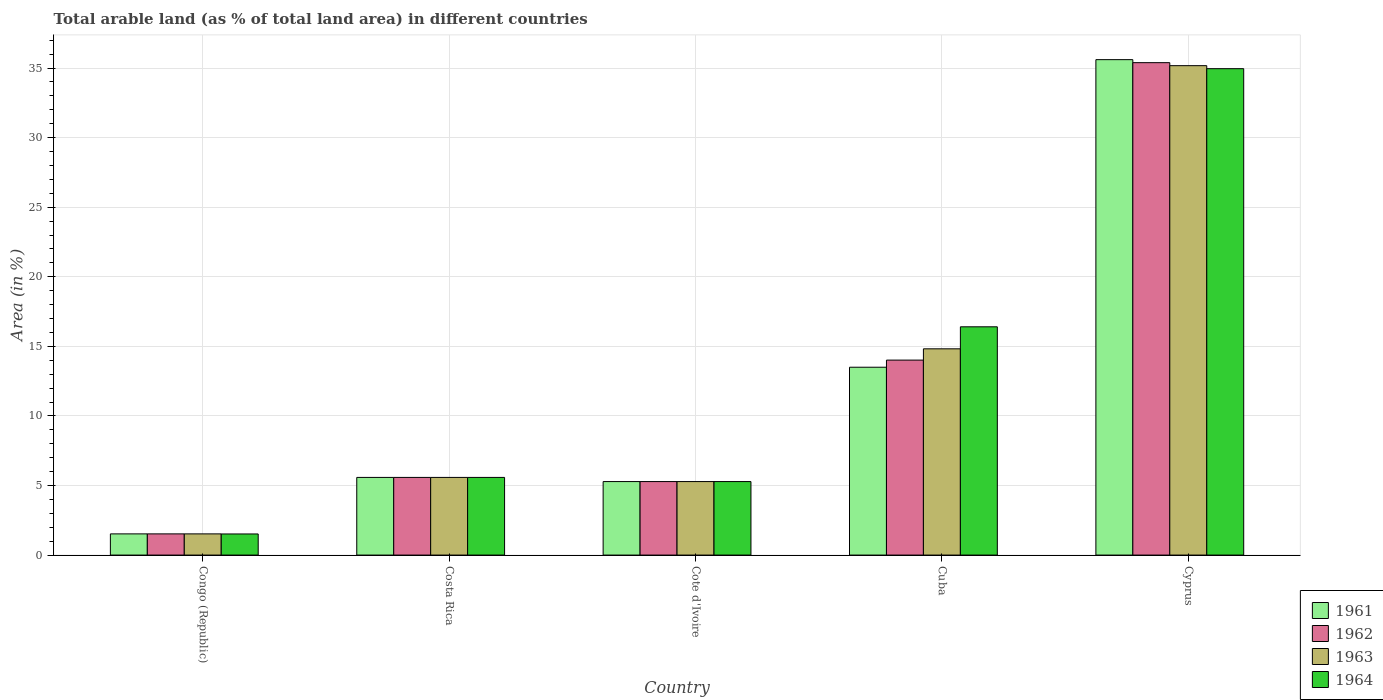Are the number of bars on each tick of the X-axis equal?
Make the answer very short. Yes. How many bars are there on the 5th tick from the left?
Keep it short and to the point. 4. How many bars are there on the 1st tick from the right?
Your answer should be very brief. 4. What is the label of the 5th group of bars from the left?
Keep it short and to the point. Cyprus. What is the percentage of arable land in 1962 in Cuba?
Provide a short and direct response. 14.01. Across all countries, what is the maximum percentage of arable land in 1963?
Ensure brevity in your answer.  35.17. Across all countries, what is the minimum percentage of arable land in 1963?
Ensure brevity in your answer.  1.52. In which country was the percentage of arable land in 1962 maximum?
Provide a short and direct response. Cyprus. In which country was the percentage of arable land in 1961 minimum?
Your answer should be compact. Congo (Republic). What is the total percentage of arable land in 1964 in the graph?
Offer a terse response. 63.74. What is the difference between the percentage of arable land in 1962 in Congo (Republic) and that in Cyprus?
Offer a terse response. -33.87. What is the difference between the percentage of arable land in 1963 in Cyprus and the percentage of arable land in 1961 in Congo (Republic)?
Your answer should be very brief. 33.65. What is the average percentage of arable land in 1961 per country?
Provide a succinct answer. 12.3. What is the difference between the percentage of arable land of/in 1963 and percentage of arable land of/in 1961 in Congo (Republic)?
Offer a terse response. 0. What is the ratio of the percentage of arable land in 1964 in Congo (Republic) to that in Cuba?
Your answer should be very brief. 0.09. Is the percentage of arable land in 1963 in Congo (Republic) less than that in Cyprus?
Your answer should be compact. Yes. What is the difference between the highest and the second highest percentage of arable land in 1962?
Offer a very short reply. 29.81. What is the difference between the highest and the lowest percentage of arable land in 1961?
Your answer should be compact. 34.08. Is the sum of the percentage of arable land in 1964 in Costa Rica and Cyprus greater than the maximum percentage of arable land in 1962 across all countries?
Your answer should be very brief. Yes. Is it the case that in every country, the sum of the percentage of arable land in 1963 and percentage of arable land in 1962 is greater than the sum of percentage of arable land in 1961 and percentage of arable land in 1964?
Make the answer very short. No. What does the 4th bar from the left in Costa Rica represents?
Your answer should be compact. 1964. What does the 1st bar from the right in Cote d'Ivoire represents?
Provide a succinct answer. 1964. Are all the bars in the graph horizontal?
Ensure brevity in your answer.  No. How many countries are there in the graph?
Your response must be concise. 5. What is the difference between two consecutive major ticks on the Y-axis?
Your answer should be very brief. 5. Does the graph contain any zero values?
Ensure brevity in your answer.  No. Where does the legend appear in the graph?
Keep it short and to the point. Bottom right. How many legend labels are there?
Offer a terse response. 4. How are the legend labels stacked?
Offer a very short reply. Vertical. What is the title of the graph?
Offer a terse response. Total arable land (as % of total land area) in different countries. What is the label or title of the Y-axis?
Give a very brief answer. Area (in %). What is the Area (in %) in 1961 in Congo (Republic)?
Offer a terse response. 1.52. What is the Area (in %) of 1962 in Congo (Republic)?
Ensure brevity in your answer.  1.52. What is the Area (in %) in 1963 in Congo (Republic)?
Keep it short and to the point. 1.52. What is the Area (in %) in 1964 in Congo (Republic)?
Ensure brevity in your answer.  1.52. What is the Area (in %) of 1961 in Costa Rica?
Provide a short and direct response. 5.58. What is the Area (in %) of 1962 in Costa Rica?
Provide a short and direct response. 5.58. What is the Area (in %) of 1963 in Costa Rica?
Your response must be concise. 5.58. What is the Area (in %) of 1964 in Costa Rica?
Offer a very short reply. 5.58. What is the Area (in %) in 1961 in Cote d'Ivoire?
Make the answer very short. 5.28. What is the Area (in %) in 1962 in Cote d'Ivoire?
Your response must be concise. 5.28. What is the Area (in %) of 1963 in Cote d'Ivoire?
Provide a short and direct response. 5.28. What is the Area (in %) of 1964 in Cote d'Ivoire?
Make the answer very short. 5.28. What is the Area (in %) in 1961 in Cuba?
Your answer should be compact. 13.5. What is the Area (in %) in 1962 in Cuba?
Your answer should be very brief. 14.01. What is the Area (in %) of 1963 in Cuba?
Provide a succinct answer. 14.82. What is the Area (in %) of 1964 in Cuba?
Make the answer very short. 16.41. What is the Area (in %) in 1961 in Cyprus?
Provide a short and direct response. 35.61. What is the Area (in %) in 1962 in Cyprus?
Your answer should be very brief. 35.39. What is the Area (in %) of 1963 in Cyprus?
Your answer should be very brief. 35.17. What is the Area (in %) in 1964 in Cyprus?
Provide a succinct answer. 34.96. Across all countries, what is the maximum Area (in %) in 1961?
Provide a short and direct response. 35.61. Across all countries, what is the maximum Area (in %) of 1962?
Provide a succinct answer. 35.39. Across all countries, what is the maximum Area (in %) in 1963?
Provide a short and direct response. 35.17. Across all countries, what is the maximum Area (in %) in 1964?
Make the answer very short. 34.96. Across all countries, what is the minimum Area (in %) in 1961?
Offer a terse response. 1.52. Across all countries, what is the minimum Area (in %) in 1962?
Offer a very short reply. 1.52. Across all countries, what is the minimum Area (in %) of 1963?
Provide a short and direct response. 1.52. Across all countries, what is the minimum Area (in %) in 1964?
Keep it short and to the point. 1.52. What is the total Area (in %) in 1961 in the graph?
Keep it short and to the point. 61.49. What is the total Area (in %) in 1962 in the graph?
Offer a terse response. 61.79. What is the total Area (in %) in 1963 in the graph?
Make the answer very short. 62.38. What is the total Area (in %) in 1964 in the graph?
Your answer should be compact. 63.74. What is the difference between the Area (in %) of 1961 in Congo (Republic) and that in Costa Rica?
Your answer should be compact. -4.06. What is the difference between the Area (in %) in 1962 in Congo (Republic) and that in Costa Rica?
Your answer should be compact. -4.06. What is the difference between the Area (in %) in 1963 in Congo (Republic) and that in Costa Rica?
Ensure brevity in your answer.  -4.06. What is the difference between the Area (in %) in 1964 in Congo (Republic) and that in Costa Rica?
Your answer should be very brief. -4.06. What is the difference between the Area (in %) in 1961 in Congo (Republic) and that in Cote d'Ivoire?
Your answer should be compact. -3.76. What is the difference between the Area (in %) of 1962 in Congo (Republic) and that in Cote d'Ivoire?
Ensure brevity in your answer.  -3.76. What is the difference between the Area (in %) of 1963 in Congo (Republic) and that in Cote d'Ivoire?
Offer a terse response. -3.76. What is the difference between the Area (in %) in 1964 in Congo (Republic) and that in Cote d'Ivoire?
Offer a very short reply. -3.77. What is the difference between the Area (in %) in 1961 in Congo (Republic) and that in Cuba?
Offer a very short reply. -11.98. What is the difference between the Area (in %) of 1962 in Congo (Republic) and that in Cuba?
Provide a succinct answer. -12.49. What is the difference between the Area (in %) in 1963 in Congo (Republic) and that in Cuba?
Ensure brevity in your answer.  -13.3. What is the difference between the Area (in %) of 1964 in Congo (Republic) and that in Cuba?
Offer a very short reply. -14.89. What is the difference between the Area (in %) of 1961 in Congo (Republic) and that in Cyprus?
Give a very brief answer. -34.08. What is the difference between the Area (in %) of 1962 in Congo (Republic) and that in Cyprus?
Your answer should be compact. -33.87. What is the difference between the Area (in %) of 1963 in Congo (Republic) and that in Cyprus?
Provide a short and direct response. -33.65. What is the difference between the Area (in %) in 1964 in Congo (Republic) and that in Cyprus?
Offer a very short reply. -33.44. What is the difference between the Area (in %) of 1961 in Costa Rica and that in Cote d'Ivoire?
Offer a very short reply. 0.3. What is the difference between the Area (in %) of 1962 in Costa Rica and that in Cote d'Ivoire?
Give a very brief answer. 0.3. What is the difference between the Area (in %) of 1963 in Costa Rica and that in Cote d'Ivoire?
Your response must be concise. 0.3. What is the difference between the Area (in %) in 1964 in Costa Rica and that in Cote d'Ivoire?
Offer a very short reply. 0.3. What is the difference between the Area (in %) of 1961 in Costa Rica and that in Cuba?
Make the answer very short. -7.92. What is the difference between the Area (in %) in 1962 in Costa Rica and that in Cuba?
Provide a short and direct response. -8.43. What is the difference between the Area (in %) in 1963 in Costa Rica and that in Cuba?
Offer a terse response. -9.24. What is the difference between the Area (in %) in 1964 in Costa Rica and that in Cuba?
Keep it short and to the point. -10.82. What is the difference between the Area (in %) in 1961 in Costa Rica and that in Cyprus?
Give a very brief answer. -30.02. What is the difference between the Area (in %) of 1962 in Costa Rica and that in Cyprus?
Give a very brief answer. -29.81. What is the difference between the Area (in %) of 1963 in Costa Rica and that in Cyprus?
Make the answer very short. -29.59. What is the difference between the Area (in %) in 1964 in Costa Rica and that in Cyprus?
Your answer should be very brief. -29.38. What is the difference between the Area (in %) in 1961 in Cote d'Ivoire and that in Cuba?
Keep it short and to the point. -8.22. What is the difference between the Area (in %) in 1962 in Cote d'Ivoire and that in Cuba?
Provide a short and direct response. -8.73. What is the difference between the Area (in %) in 1963 in Cote d'Ivoire and that in Cuba?
Keep it short and to the point. -9.54. What is the difference between the Area (in %) of 1964 in Cote d'Ivoire and that in Cuba?
Offer a very short reply. -11.12. What is the difference between the Area (in %) of 1961 in Cote d'Ivoire and that in Cyprus?
Provide a succinct answer. -30.32. What is the difference between the Area (in %) in 1962 in Cote d'Ivoire and that in Cyprus?
Provide a succinct answer. -30.11. What is the difference between the Area (in %) of 1963 in Cote d'Ivoire and that in Cyprus?
Keep it short and to the point. -29.89. What is the difference between the Area (in %) in 1964 in Cote d'Ivoire and that in Cyprus?
Offer a terse response. -29.67. What is the difference between the Area (in %) in 1961 in Cuba and that in Cyprus?
Give a very brief answer. -22.11. What is the difference between the Area (in %) of 1962 in Cuba and that in Cyprus?
Give a very brief answer. -21.38. What is the difference between the Area (in %) of 1963 in Cuba and that in Cyprus?
Ensure brevity in your answer.  -20.35. What is the difference between the Area (in %) of 1964 in Cuba and that in Cyprus?
Give a very brief answer. -18.55. What is the difference between the Area (in %) of 1961 in Congo (Republic) and the Area (in %) of 1962 in Costa Rica?
Keep it short and to the point. -4.06. What is the difference between the Area (in %) in 1961 in Congo (Republic) and the Area (in %) in 1963 in Costa Rica?
Make the answer very short. -4.06. What is the difference between the Area (in %) of 1961 in Congo (Republic) and the Area (in %) of 1964 in Costa Rica?
Provide a short and direct response. -4.06. What is the difference between the Area (in %) in 1962 in Congo (Republic) and the Area (in %) in 1963 in Costa Rica?
Your answer should be very brief. -4.06. What is the difference between the Area (in %) in 1962 in Congo (Republic) and the Area (in %) in 1964 in Costa Rica?
Your answer should be very brief. -4.06. What is the difference between the Area (in %) of 1963 in Congo (Republic) and the Area (in %) of 1964 in Costa Rica?
Offer a terse response. -4.06. What is the difference between the Area (in %) of 1961 in Congo (Republic) and the Area (in %) of 1962 in Cote d'Ivoire?
Your answer should be compact. -3.76. What is the difference between the Area (in %) of 1961 in Congo (Republic) and the Area (in %) of 1963 in Cote d'Ivoire?
Offer a terse response. -3.76. What is the difference between the Area (in %) of 1961 in Congo (Republic) and the Area (in %) of 1964 in Cote d'Ivoire?
Ensure brevity in your answer.  -3.76. What is the difference between the Area (in %) of 1962 in Congo (Republic) and the Area (in %) of 1963 in Cote d'Ivoire?
Keep it short and to the point. -3.76. What is the difference between the Area (in %) in 1962 in Congo (Republic) and the Area (in %) in 1964 in Cote d'Ivoire?
Your answer should be compact. -3.76. What is the difference between the Area (in %) of 1963 in Congo (Republic) and the Area (in %) of 1964 in Cote d'Ivoire?
Provide a succinct answer. -3.76. What is the difference between the Area (in %) in 1961 in Congo (Republic) and the Area (in %) in 1962 in Cuba?
Give a very brief answer. -12.49. What is the difference between the Area (in %) of 1961 in Congo (Republic) and the Area (in %) of 1963 in Cuba?
Provide a short and direct response. -13.3. What is the difference between the Area (in %) of 1961 in Congo (Republic) and the Area (in %) of 1964 in Cuba?
Offer a terse response. -14.88. What is the difference between the Area (in %) of 1962 in Congo (Republic) and the Area (in %) of 1963 in Cuba?
Keep it short and to the point. -13.3. What is the difference between the Area (in %) of 1962 in Congo (Republic) and the Area (in %) of 1964 in Cuba?
Make the answer very short. -14.88. What is the difference between the Area (in %) in 1963 in Congo (Republic) and the Area (in %) in 1964 in Cuba?
Provide a short and direct response. -14.88. What is the difference between the Area (in %) of 1961 in Congo (Republic) and the Area (in %) of 1962 in Cyprus?
Your answer should be compact. -33.87. What is the difference between the Area (in %) of 1961 in Congo (Republic) and the Area (in %) of 1963 in Cyprus?
Offer a terse response. -33.65. What is the difference between the Area (in %) in 1961 in Congo (Republic) and the Area (in %) in 1964 in Cyprus?
Ensure brevity in your answer.  -33.43. What is the difference between the Area (in %) in 1962 in Congo (Republic) and the Area (in %) in 1963 in Cyprus?
Keep it short and to the point. -33.65. What is the difference between the Area (in %) of 1962 in Congo (Republic) and the Area (in %) of 1964 in Cyprus?
Your response must be concise. -33.43. What is the difference between the Area (in %) of 1963 in Congo (Republic) and the Area (in %) of 1964 in Cyprus?
Your response must be concise. -33.43. What is the difference between the Area (in %) of 1961 in Costa Rica and the Area (in %) of 1962 in Cote d'Ivoire?
Your answer should be compact. 0.3. What is the difference between the Area (in %) in 1961 in Costa Rica and the Area (in %) in 1963 in Cote d'Ivoire?
Keep it short and to the point. 0.3. What is the difference between the Area (in %) of 1961 in Costa Rica and the Area (in %) of 1964 in Cote d'Ivoire?
Offer a terse response. 0.3. What is the difference between the Area (in %) in 1962 in Costa Rica and the Area (in %) in 1963 in Cote d'Ivoire?
Your response must be concise. 0.3. What is the difference between the Area (in %) in 1962 in Costa Rica and the Area (in %) in 1964 in Cote d'Ivoire?
Offer a terse response. 0.3. What is the difference between the Area (in %) of 1963 in Costa Rica and the Area (in %) of 1964 in Cote d'Ivoire?
Provide a short and direct response. 0.3. What is the difference between the Area (in %) in 1961 in Costa Rica and the Area (in %) in 1962 in Cuba?
Make the answer very short. -8.43. What is the difference between the Area (in %) in 1961 in Costa Rica and the Area (in %) in 1963 in Cuba?
Make the answer very short. -9.24. What is the difference between the Area (in %) of 1961 in Costa Rica and the Area (in %) of 1964 in Cuba?
Your response must be concise. -10.82. What is the difference between the Area (in %) in 1962 in Costa Rica and the Area (in %) in 1963 in Cuba?
Ensure brevity in your answer.  -9.24. What is the difference between the Area (in %) in 1962 in Costa Rica and the Area (in %) in 1964 in Cuba?
Make the answer very short. -10.82. What is the difference between the Area (in %) in 1963 in Costa Rica and the Area (in %) in 1964 in Cuba?
Make the answer very short. -10.82. What is the difference between the Area (in %) of 1961 in Costa Rica and the Area (in %) of 1962 in Cyprus?
Ensure brevity in your answer.  -29.81. What is the difference between the Area (in %) in 1961 in Costa Rica and the Area (in %) in 1963 in Cyprus?
Make the answer very short. -29.59. What is the difference between the Area (in %) in 1961 in Costa Rica and the Area (in %) in 1964 in Cyprus?
Offer a very short reply. -29.38. What is the difference between the Area (in %) of 1962 in Costa Rica and the Area (in %) of 1963 in Cyprus?
Your answer should be compact. -29.59. What is the difference between the Area (in %) in 1962 in Costa Rica and the Area (in %) in 1964 in Cyprus?
Your answer should be compact. -29.38. What is the difference between the Area (in %) in 1963 in Costa Rica and the Area (in %) in 1964 in Cyprus?
Make the answer very short. -29.38. What is the difference between the Area (in %) of 1961 in Cote d'Ivoire and the Area (in %) of 1962 in Cuba?
Offer a very short reply. -8.73. What is the difference between the Area (in %) of 1961 in Cote d'Ivoire and the Area (in %) of 1963 in Cuba?
Offer a terse response. -9.54. What is the difference between the Area (in %) in 1961 in Cote d'Ivoire and the Area (in %) in 1964 in Cuba?
Offer a terse response. -11.12. What is the difference between the Area (in %) of 1962 in Cote d'Ivoire and the Area (in %) of 1963 in Cuba?
Your answer should be compact. -9.54. What is the difference between the Area (in %) of 1962 in Cote d'Ivoire and the Area (in %) of 1964 in Cuba?
Offer a very short reply. -11.12. What is the difference between the Area (in %) in 1963 in Cote d'Ivoire and the Area (in %) in 1964 in Cuba?
Your answer should be very brief. -11.12. What is the difference between the Area (in %) in 1961 in Cote d'Ivoire and the Area (in %) in 1962 in Cyprus?
Your response must be concise. -30.11. What is the difference between the Area (in %) in 1961 in Cote d'Ivoire and the Area (in %) in 1963 in Cyprus?
Keep it short and to the point. -29.89. What is the difference between the Area (in %) in 1961 in Cote d'Ivoire and the Area (in %) in 1964 in Cyprus?
Provide a succinct answer. -29.67. What is the difference between the Area (in %) in 1962 in Cote d'Ivoire and the Area (in %) in 1963 in Cyprus?
Provide a short and direct response. -29.89. What is the difference between the Area (in %) in 1962 in Cote d'Ivoire and the Area (in %) in 1964 in Cyprus?
Your answer should be very brief. -29.67. What is the difference between the Area (in %) in 1963 in Cote d'Ivoire and the Area (in %) in 1964 in Cyprus?
Ensure brevity in your answer.  -29.67. What is the difference between the Area (in %) of 1961 in Cuba and the Area (in %) of 1962 in Cyprus?
Your answer should be very brief. -21.89. What is the difference between the Area (in %) of 1961 in Cuba and the Area (in %) of 1963 in Cyprus?
Make the answer very short. -21.67. What is the difference between the Area (in %) in 1961 in Cuba and the Area (in %) in 1964 in Cyprus?
Keep it short and to the point. -21.46. What is the difference between the Area (in %) in 1962 in Cuba and the Area (in %) in 1963 in Cyprus?
Offer a very short reply. -21.16. What is the difference between the Area (in %) in 1962 in Cuba and the Area (in %) in 1964 in Cyprus?
Your answer should be compact. -20.94. What is the difference between the Area (in %) in 1963 in Cuba and the Area (in %) in 1964 in Cyprus?
Give a very brief answer. -20.13. What is the average Area (in %) in 1961 per country?
Your response must be concise. 12.3. What is the average Area (in %) in 1962 per country?
Give a very brief answer. 12.36. What is the average Area (in %) in 1963 per country?
Provide a succinct answer. 12.48. What is the average Area (in %) in 1964 per country?
Provide a short and direct response. 12.75. What is the difference between the Area (in %) in 1961 and Area (in %) in 1962 in Congo (Republic)?
Provide a short and direct response. 0. What is the difference between the Area (in %) of 1961 and Area (in %) of 1964 in Congo (Republic)?
Ensure brevity in your answer.  0.01. What is the difference between the Area (in %) in 1962 and Area (in %) in 1963 in Congo (Republic)?
Offer a terse response. 0. What is the difference between the Area (in %) in 1962 and Area (in %) in 1964 in Congo (Republic)?
Provide a short and direct response. 0.01. What is the difference between the Area (in %) of 1963 and Area (in %) of 1964 in Congo (Republic)?
Your answer should be compact. 0.01. What is the difference between the Area (in %) in 1961 and Area (in %) in 1963 in Costa Rica?
Your response must be concise. 0. What is the difference between the Area (in %) in 1962 and Area (in %) in 1963 in Costa Rica?
Make the answer very short. 0. What is the difference between the Area (in %) of 1962 and Area (in %) of 1964 in Costa Rica?
Ensure brevity in your answer.  0. What is the difference between the Area (in %) of 1963 and Area (in %) of 1964 in Costa Rica?
Give a very brief answer. 0. What is the difference between the Area (in %) of 1961 and Area (in %) of 1962 in Cote d'Ivoire?
Make the answer very short. 0. What is the difference between the Area (in %) in 1963 and Area (in %) in 1964 in Cote d'Ivoire?
Make the answer very short. 0. What is the difference between the Area (in %) of 1961 and Area (in %) of 1962 in Cuba?
Give a very brief answer. -0.51. What is the difference between the Area (in %) of 1961 and Area (in %) of 1963 in Cuba?
Ensure brevity in your answer.  -1.32. What is the difference between the Area (in %) of 1961 and Area (in %) of 1964 in Cuba?
Provide a short and direct response. -2.9. What is the difference between the Area (in %) of 1962 and Area (in %) of 1963 in Cuba?
Your answer should be very brief. -0.81. What is the difference between the Area (in %) in 1962 and Area (in %) in 1964 in Cuba?
Give a very brief answer. -2.39. What is the difference between the Area (in %) of 1963 and Area (in %) of 1964 in Cuba?
Your answer should be very brief. -1.58. What is the difference between the Area (in %) of 1961 and Area (in %) of 1962 in Cyprus?
Make the answer very short. 0.22. What is the difference between the Area (in %) in 1961 and Area (in %) in 1963 in Cyprus?
Provide a succinct answer. 0.43. What is the difference between the Area (in %) in 1961 and Area (in %) in 1964 in Cyprus?
Make the answer very short. 0.65. What is the difference between the Area (in %) in 1962 and Area (in %) in 1963 in Cyprus?
Provide a succinct answer. 0.22. What is the difference between the Area (in %) in 1962 and Area (in %) in 1964 in Cyprus?
Provide a succinct answer. 0.43. What is the difference between the Area (in %) in 1963 and Area (in %) in 1964 in Cyprus?
Offer a terse response. 0.22. What is the ratio of the Area (in %) of 1961 in Congo (Republic) to that in Costa Rica?
Your response must be concise. 0.27. What is the ratio of the Area (in %) in 1962 in Congo (Republic) to that in Costa Rica?
Offer a very short reply. 0.27. What is the ratio of the Area (in %) of 1963 in Congo (Republic) to that in Costa Rica?
Give a very brief answer. 0.27. What is the ratio of the Area (in %) of 1964 in Congo (Republic) to that in Costa Rica?
Give a very brief answer. 0.27. What is the ratio of the Area (in %) of 1961 in Congo (Republic) to that in Cote d'Ivoire?
Provide a short and direct response. 0.29. What is the ratio of the Area (in %) of 1962 in Congo (Republic) to that in Cote d'Ivoire?
Your response must be concise. 0.29. What is the ratio of the Area (in %) of 1963 in Congo (Republic) to that in Cote d'Ivoire?
Your answer should be very brief. 0.29. What is the ratio of the Area (in %) in 1964 in Congo (Republic) to that in Cote d'Ivoire?
Ensure brevity in your answer.  0.29. What is the ratio of the Area (in %) of 1961 in Congo (Republic) to that in Cuba?
Give a very brief answer. 0.11. What is the ratio of the Area (in %) of 1962 in Congo (Republic) to that in Cuba?
Offer a terse response. 0.11. What is the ratio of the Area (in %) in 1963 in Congo (Republic) to that in Cuba?
Your answer should be very brief. 0.1. What is the ratio of the Area (in %) in 1964 in Congo (Republic) to that in Cuba?
Your answer should be compact. 0.09. What is the ratio of the Area (in %) in 1961 in Congo (Republic) to that in Cyprus?
Provide a short and direct response. 0.04. What is the ratio of the Area (in %) of 1962 in Congo (Republic) to that in Cyprus?
Make the answer very short. 0.04. What is the ratio of the Area (in %) of 1963 in Congo (Republic) to that in Cyprus?
Your response must be concise. 0.04. What is the ratio of the Area (in %) in 1964 in Congo (Republic) to that in Cyprus?
Keep it short and to the point. 0.04. What is the ratio of the Area (in %) in 1961 in Costa Rica to that in Cote d'Ivoire?
Your answer should be very brief. 1.06. What is the ratio of the Area (in %) of 1962 in Costa Rica to that in Cote d'Ivoire?
Provide a succinct answer. 1.06. What is the ratio of the Area (in %) of 1963 in Costa Rica to that in Cote d'Ivoire?
Offer a very short reply. 1.06. What is the ratio of the Area (in %) in 1964 in Costa Rica to that in Cote d'Ivoire?
Your answer should be compact. 1.06. What is the ratio of the Area (in %) in 1961 in Costa Rica to that in Cuba?
Your response must be concise. 0.41. What is the ratio of the Area (in %) of 1962 in Costa Rica to that in Cuba?
Keep it short and to the point. 0.4. What is the ratio of the Area (in %) in 1963 in Costa Rica to that in Cuba?
Give a very brief answer. 0.38. What is the ratio of the Area (in %) of 1964 in Costa Rica to that in Cuba?
Offer a very short reply. 0.34. What is the ratio of the Area (in %) of 1961 in Costa Rica to that in Cyprus?
Provide a short and direct response. 0.16. What is the ratio of the Area (in %) of 1962 in Costa Rica to that in Cyprus?
Make the answer very short. 0.16. What is the ratio of the Area (in %) in 1963 in Costa Rica to that in Cyprus?
Keep it short and to the point. 0.16. What is the ratio of the Area (in %) of 1964 in Costa Rica to that in Cyprus?
Give a very brief answer. 0.16. What is the ratio of the Area (in %) of 1961 in Cote d'Ivoire to that in Cuba?
Your answer should be very brief. 0.39. What is the ratio of the Area (in %) of 1962 in Cote d'Ivoire to that in Cuba?
Provide a short and direct response. 0.38. What is the ratio of the Area (in %) in 1963 in Cote d'Ivoire to that in Cuba?
Make the answer very short. 0.36. What is the ratio of the Area (in %) of 1964 in Cote d'Ivoire to that in Cuba?
Give a very brief answer. 0.32. What is the ratio of the Area (in %) of 1961 in Cote d'Ivoire to that in Cyprus?
Make the answer very short. 0.15. What is the ratio of the Area (in %) of 1962 in Cote d'Ivoire to that in Cyprus?
Give a very brief answer. 0.15. What is the ratio of the Area (in %) in 1963 in Cote d'Ivoire to that in Cyprus?
Give a very brief answer. 0.15. What is the ratio of the Area (in %) in 1964 in Cote d'Ivoire to that in Cyprus?
Ensure brevity in your answer.  0.15. What is the ratio of the Area (in %) of 1961 in Cuba to that in Cyprus?
Your answer should be compact. 0.38. What is the ratio of the Area (in %) of 1962 in Cuba to that in Cyprus?
Offer a terse response. 0.4. What is the ratio of the Area (in %) in 1963 in Cuba to that in Cyprus?
Ensure brevity in your answer.  0.42. What is the ratio of the Area (in %) of 1964 in Cuba to that in Cyprus?
Give a very brief answer. 0.47. What is the difference between the highest and the second highest Area (in %) in 1961?
Provide a succinct answer. 22.11. What is the difference between the highest and the second highest Area (in %) of 1962?
Make the answer very short. 21.38. What is the difference between the highest and the second highest Area (in %) of 1963?
Ensure brevity in your answer.  20.35. What is the difference between the highest and the second highest Area (in %) of 1964?
Keep it short and to the point. 18.55. What is the difference between the highest and the lowest Area (in %) of 1961?
Your answer should be very brief. 34.08. What is the difference between the highest and the lowest Area (in %) of 1962?
Your answer should be very brief. 33.87. What is the difference between the highest and the lowest Area (in %) of 1963?
Make the answer very short. 33.65. What is the difference between the highest and the lowest Area (in %) of 1964?
Provide a short and direct response. 33.44. 